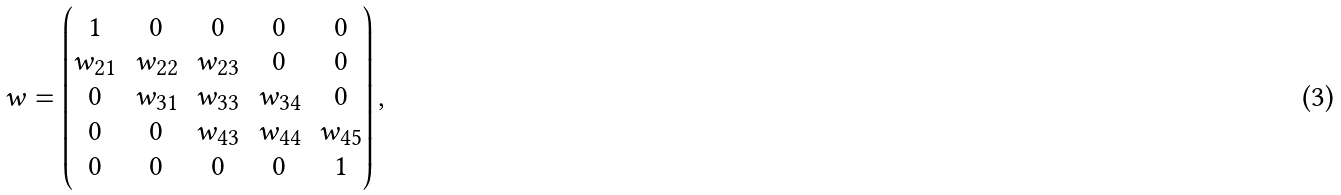Convert formula to latex. <formula><loc_0><loc_0><loc_500><loc_500>w = \begin{pmatrix} 1 & 0 & 0 & 0 & 0 \\ w _ { 2 1 } & w _ { 2 2 } & w _ { 2 3 } & 0 & 0 \\ 0 & w _ { 3 1 } & w _ { 3 3 } & w _ { 3 4 } & 0 \\ 0 & 0 & w _ { 4 3 } & w _ { 4 4 } & w _ { 4 5 } \\ 0 & 0 & 0 & 0 & 1 \end{pmatrix} ,</formula> 